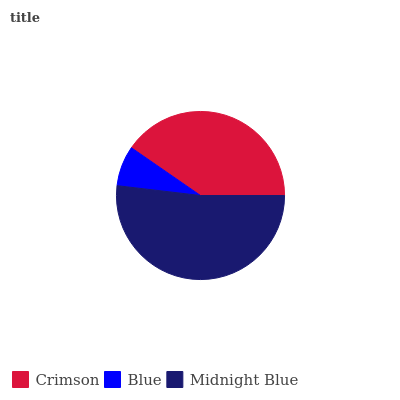Is Blue the minimum?
Answer yes or no. Yes. Is Midnight Blue the maximum?
Answer yes or no. Yes. Is Midnight Blue the minimum?
Answer yes or no. No. Is Blue the maximum?
Answer yes or no. No. Is Midnight Blue greater than Blue?
Answer yes or no. Yes. Is Blue less than Midnight Blue?
Answer yes or no. Yes. Is Blue greater than Midnight Blue?
Answer yes or no. No. Is Midnight Blue less than Blue?
Answer yes or no. No. Is Crimson the high median?
Answer yes or no. Yes. Is Crimson the low median?
Answer yes or no. Yes. Is Blue the high median?
Answer yes or no. No. Is Midnight Blue the low median?
Answer yes or no. No. 